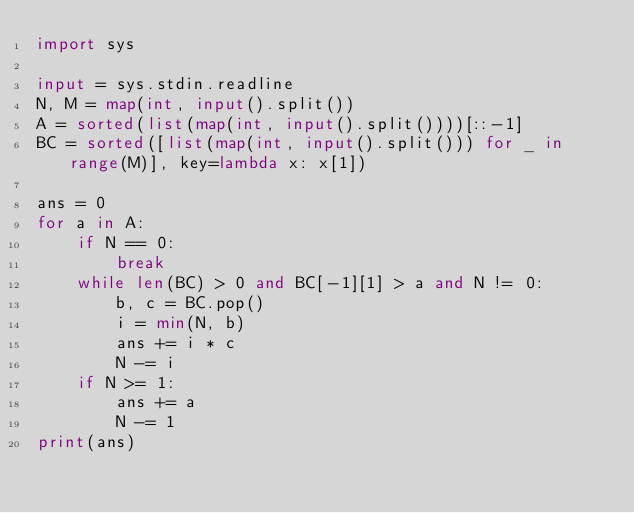Convert code to text. <code><loc_0><loc_0><loc_500><loc_500><_Python_>import sys

input = sys.stdin.readline
N, M = map(int, input().split())
A = sorted(list(map(int, input().split())))[::-1]
BC = sorted([list(map(int, input().split())) for _ in range(M)], key=lambda x: x[1])

ans = 0
for a in A:
    if N == 0:
        break
    while len(BC) > 0 and BC[-1][1] > a and N != 0:
        b, c = BC.pop()
        i = min(N, b)
        ans += i * c
        N -= i
    if N >= 1:
        ans += a
        N -= 1
print(ans)
</code> 